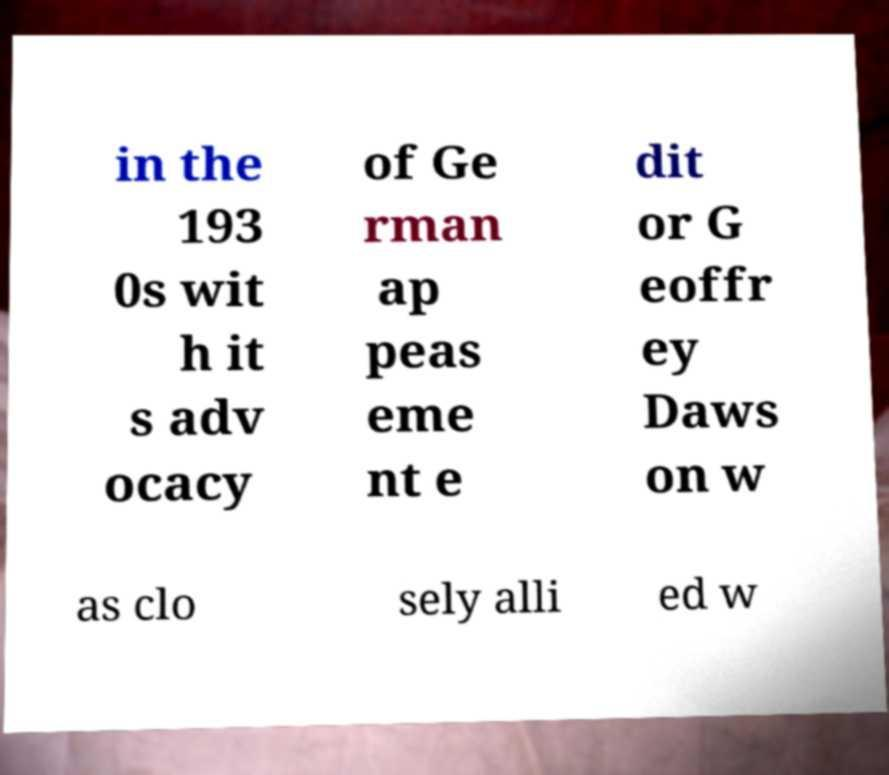For documentation purposes, I need the text within this image transcribed. Could you provide that? in the 193 0s wit h it s adv ocacy of Ge rman ap peas eme nt e dit or G eoffr ey Daws on w as clo sely alli ed w 